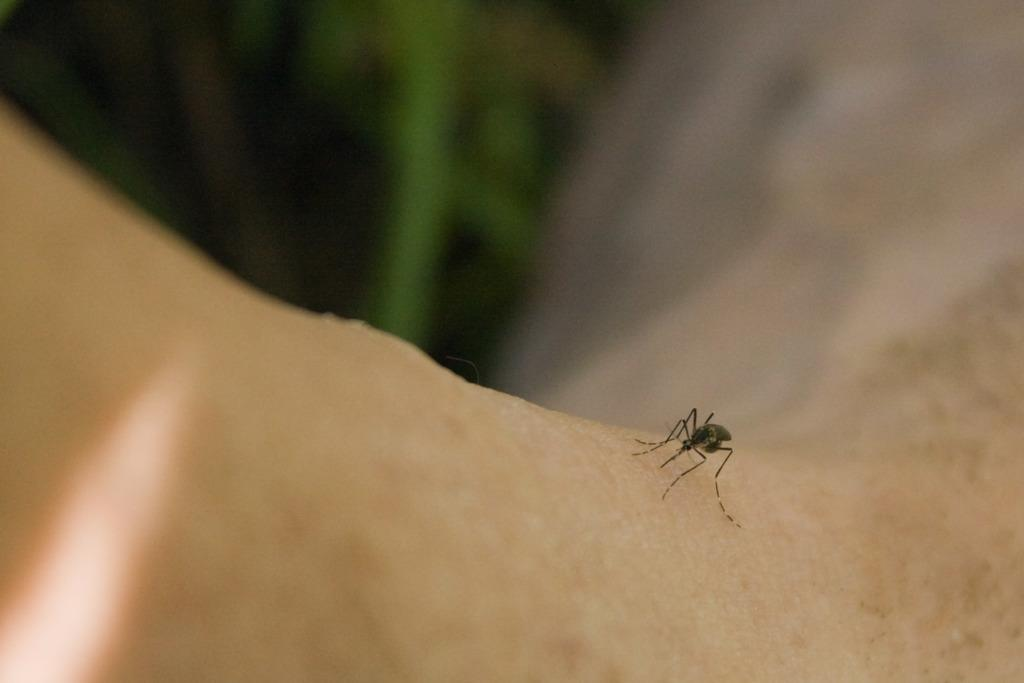What is the main subject of the picture? The main subject of the picture is a mosquito. Where is the mosquito located in the image? The mosquito is standing on a person's hand. What can be seen in the top left corner of the image? There is a green object in the top left corner of the image. Can you describe the lighting or coloring of the image? The image appears to have a dark or shadowy area. What type of beast can be seen running on the ground in the image? There is no beast or ground present in the image; it features a mosquito standing on a person's hand. Can you tell me how many cans are visible in the image? There are no cans present in the image. 